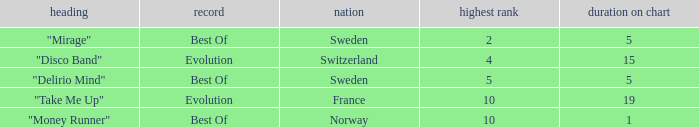What is the country with the album best of and weeks on chart is less than 5? Norway. 